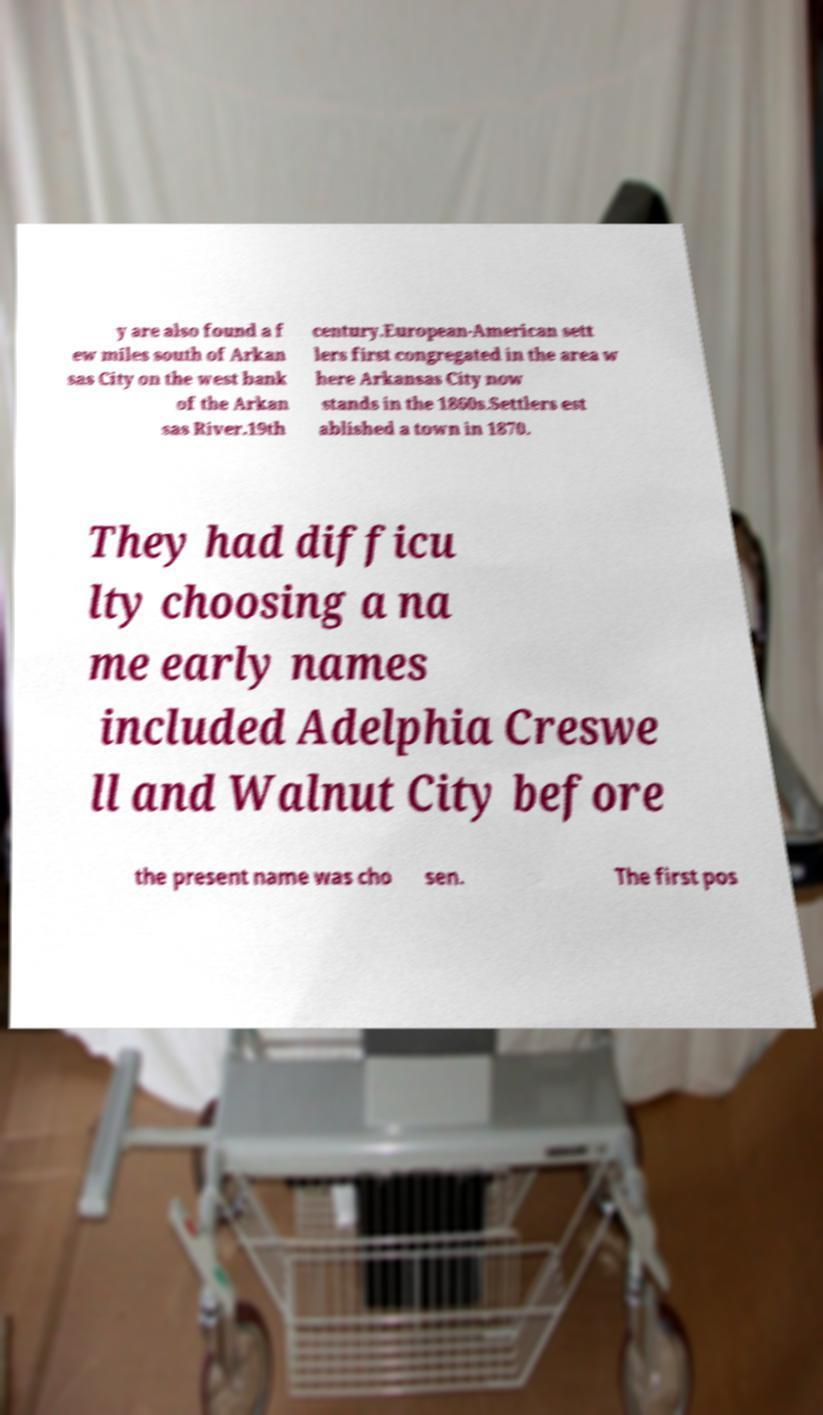What messages or text are displayed in this image? I need them in a readable, typed format. y are also found a f ew miles south of Arkan sas City on the west bank of the Arkan sas River.19th century.European-American sett lers first congregated in the area w here Arkansas City now stands in the 1860s.Settlers est ablished a town in 1870. They had difficu lty choosing a na me early names included Adelphia Creswe ll and Walnut City before the present name was cho sen. The first pos 